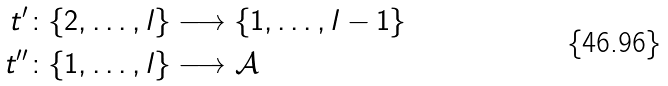Convert formula to latex. <formula><loc_0><loc_0><loc_500><loc_500>t ^ { \prime } & \colon \{ 2 , \dots , l \} \longrightarrow \{ 1 , \dots , l - 1 \} \\ t ^ { \prime \prime } & \colon \{ 1 , \dots , l \} \longrightarrow \mathcal { A }</formula> 